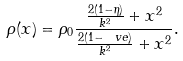<formula> <loc_0><loc_0><loc_500><loc_500>\rho ( x ) = \rho _ { 0 } \frac { \frac { 2 ( 1 - \eta ) } { k ^ { 2 } } + x ^ { 2 } } { \frac { 2 ( 1 - \ v e ) } { k ^ { 2 } } + x ^ { 2 } } .</formula> 